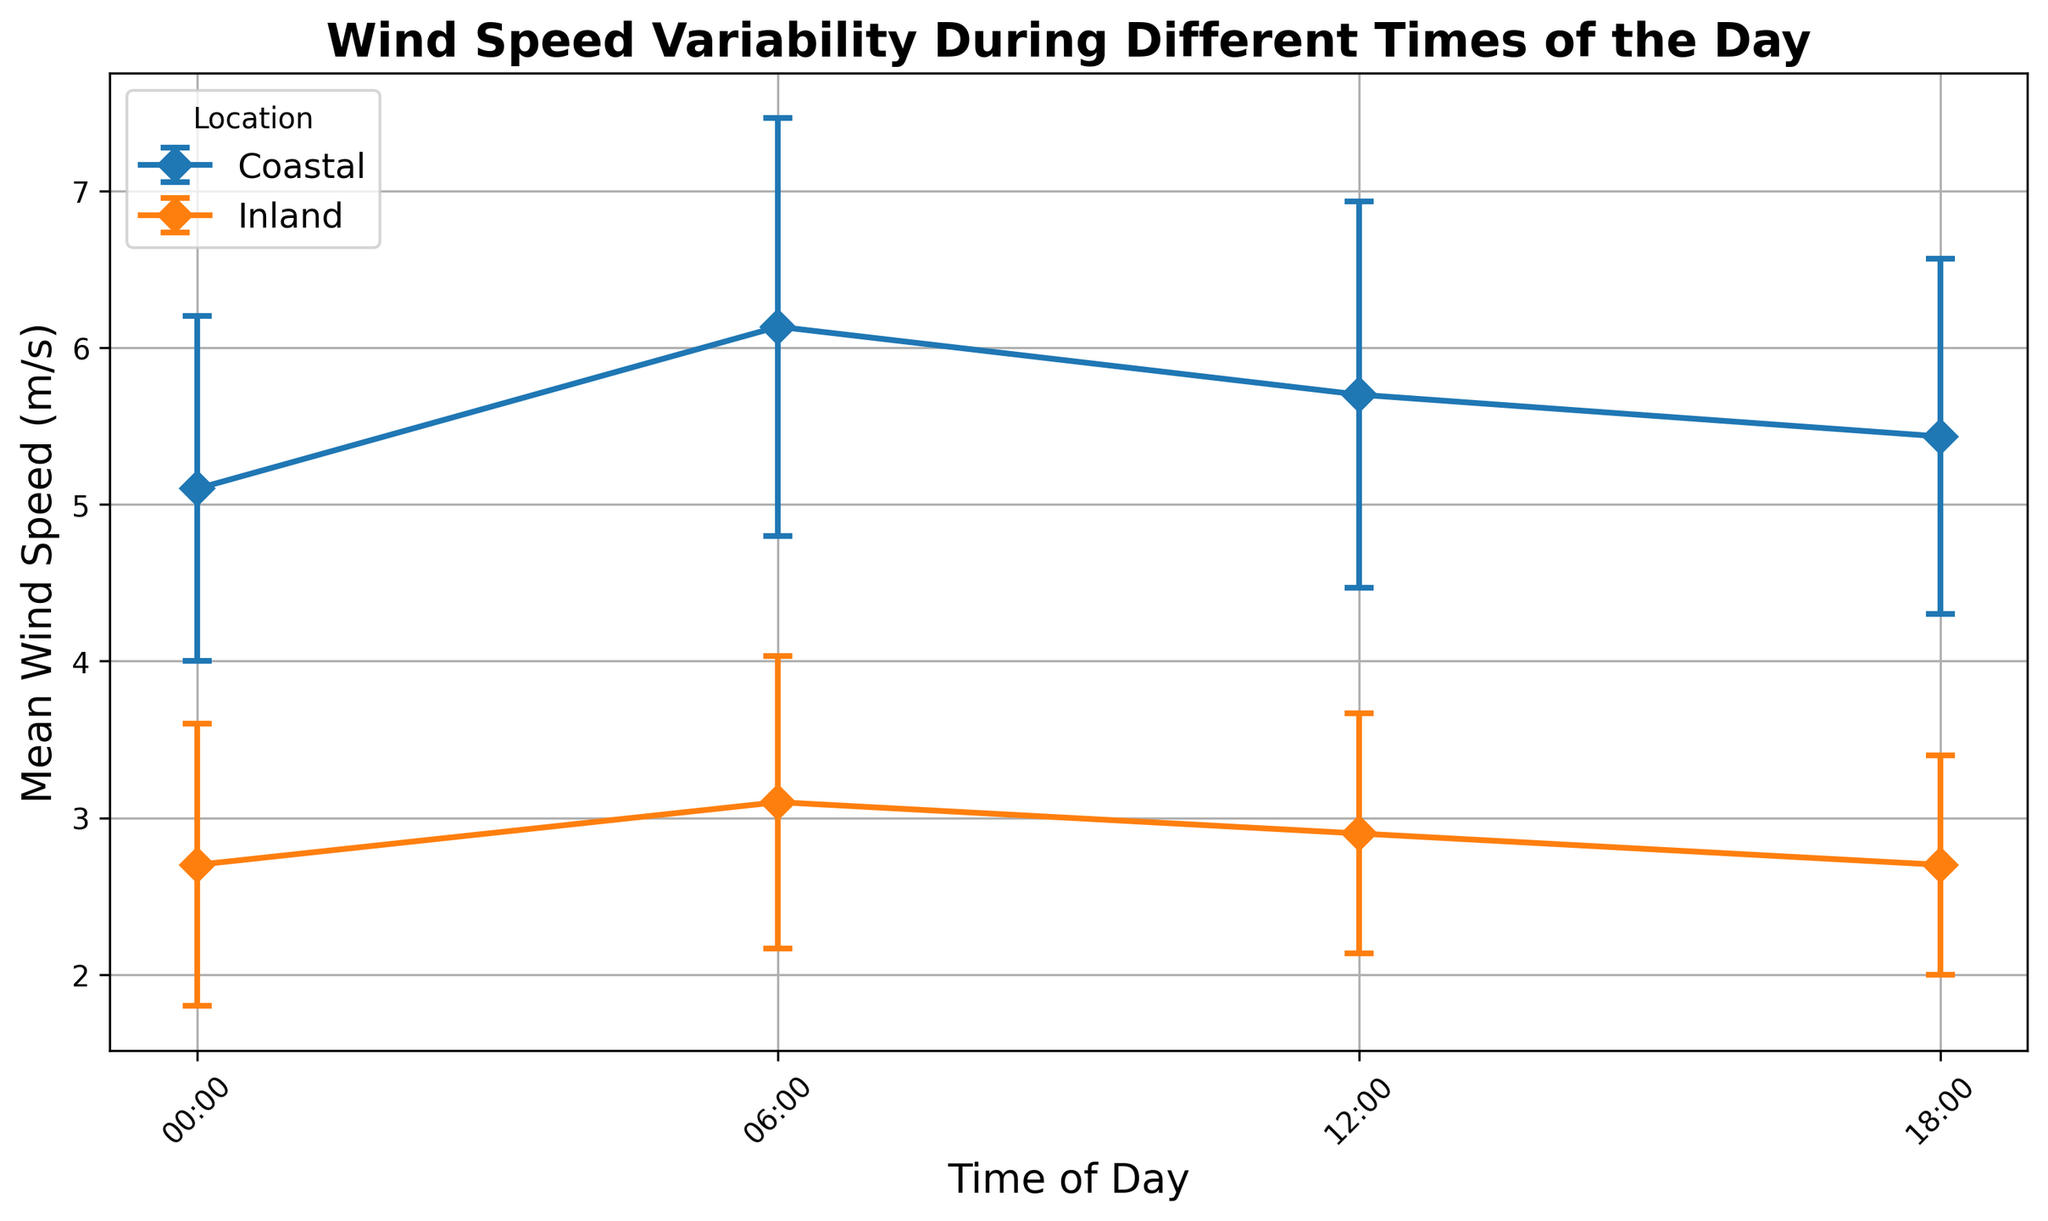How do the mean wind speeds compare between coastal and inland areas at 06:00? To answer, we look at the mean wind speeds at 06:00 on the figure. For coastal areas, it's higher compared to inland areas. This shows that coastal areas have higher wind speeds compared to inland areas at this time.
Answer: Coastal areas have higher wind speeds than inland areas What is the average mean wind speed in coastal areas throughout the day? To find the average, add up the mean wind speeds at each time point for coastal areas and divide by the number of times: (5.2 + 6.0 + 5.8 + 5.6) / 4 = 5.65 m/s.
Answer: 5.65 m/s Which location shows greater overall variability in wind speeds? To determine variability, we compare the standard deviations. Coastal areas have higher standard deviations in wind speed compared to inland areas at every time point.
Answer: Coastal areas During which time of day is the difference in mean wind speed between coastal and inland areas the smallest? To find this, we subtract the inland mean wind speed from the coastal mean wind speed for each time. The difference is smallest at 18:00.
Answer: 18:00 What's the mean wind speed difference between coastal and inland areas at 12:00? Subtract the inland mean wind speed from the coastal mean wind speed at 12:00: 5.8 - 3.0.
Answer: 2.8 m/s Do coastal areas have a consistent pattern in wind speed variability throughout the day? We observe the coastal area error bars; they remain fairly consistent in size, signifying similar variability at different times.
Answer: Yes, fairly consistent At which time is the inland area's wind speed variability the lowest? The smallest error bar in the inland area indicates the lowest variability at 18:00.
Answer: 18:00 Which time of day shows the highest mean wind speed for any location? By comparing the mean wind speeds, the highest value is seen at 06:00 for coastal areas.
Answer: 06:00 By how much does the mean wind speed in coastal areas decrease from 06:00 to 18:00? Subtract the mean wind speed at 18:00 from that at 06:00 for coastal areas: 6.0 - 5.6.
Answer: 0.4 m/s 